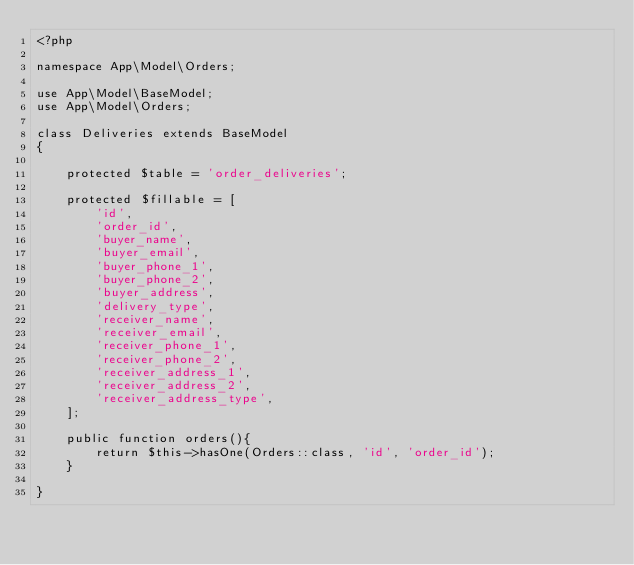Convert code to text. <code><loc_0><loc_0><loc_500><loc_500><_PHP_><?php

namespace App\Model\Orders;

use App\Model\BaseModel;
use App\Model\Orders;

class Deliveries extends BaseModel
{

    protected $table = 'order_deliveries';

    protected $fillable = [
        'id',
        'order_id',
        'buyer_name',
        'buyer_email',
        'buyer_phone_1',
        'buyer_phone_2',
        'buyer_address',
        'delivery_type',
        'receiver_name',
        'receiver_email',
        'receiver_phone_1',
        'receiver_phone_2',
        'receiver_address_1',
        'receiver_address_2',
        'receiver_address_type',
    ];

    public function orders(){
        return $this->hasOne(Orders::class, 'id', 'order_id');
    }

}</code> 